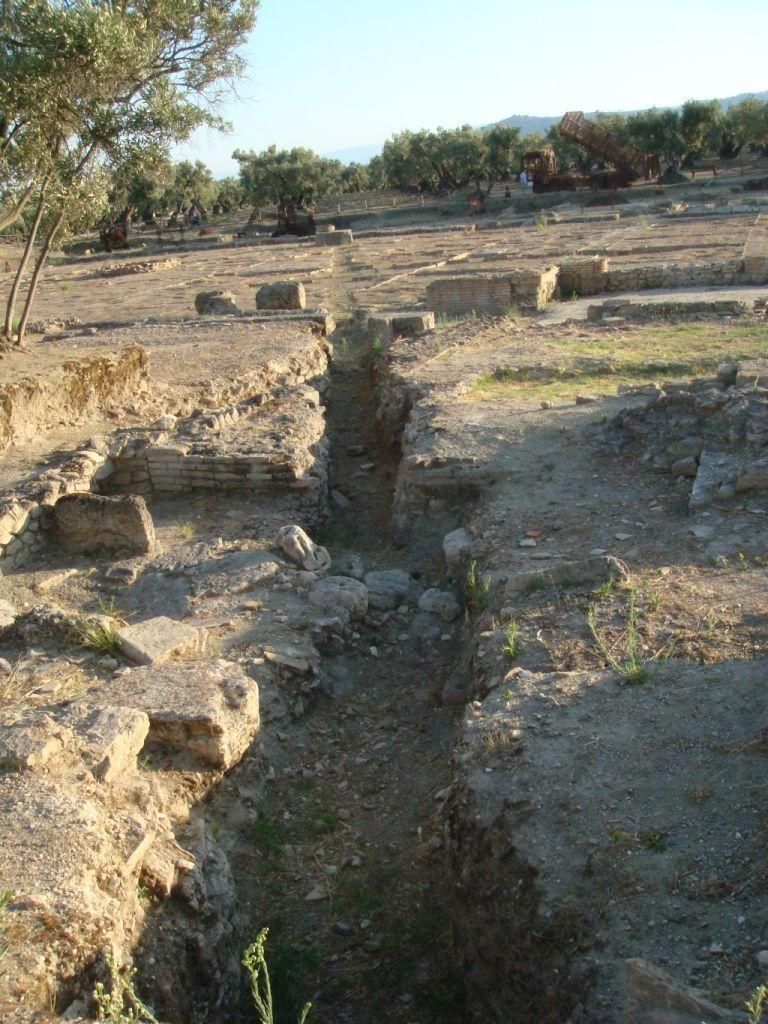What type of natural materials can be seen in the image? There are stones and sand visible in the image. What might have been used to create the dug hole in the image? The dug hole in the image was likely created by digging with a tool or hands. What type of vegetation is present in the image? There are trees in the image. What is visible in the background of the image? The sky is visible in the image. What type of bead is used to decorate the basket in the image? There is no basket or bead present in the image. What is the texture of the stones in the image? The texture of the stones in the image cannot be determined from the image alone, as texture is a tactile quality. 